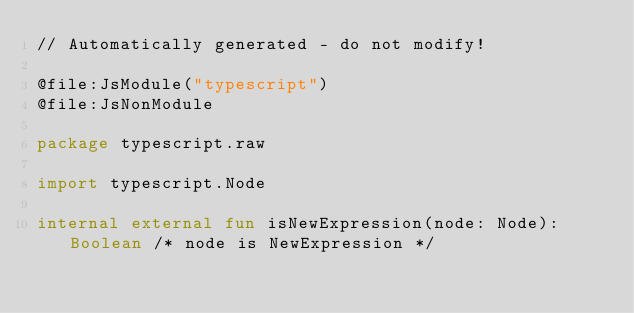<code> <loc_0><loc_0><loc_500><loc_500><_Kotlin_>// Automatically generated - do not modify!

@file:JsModule("typescript")
@file:JsNonModule

package typescript.raw

import typescript.Node

internal external fun isNewExpression(node: Node): Boolean /* node is NewExpression */
</code> 